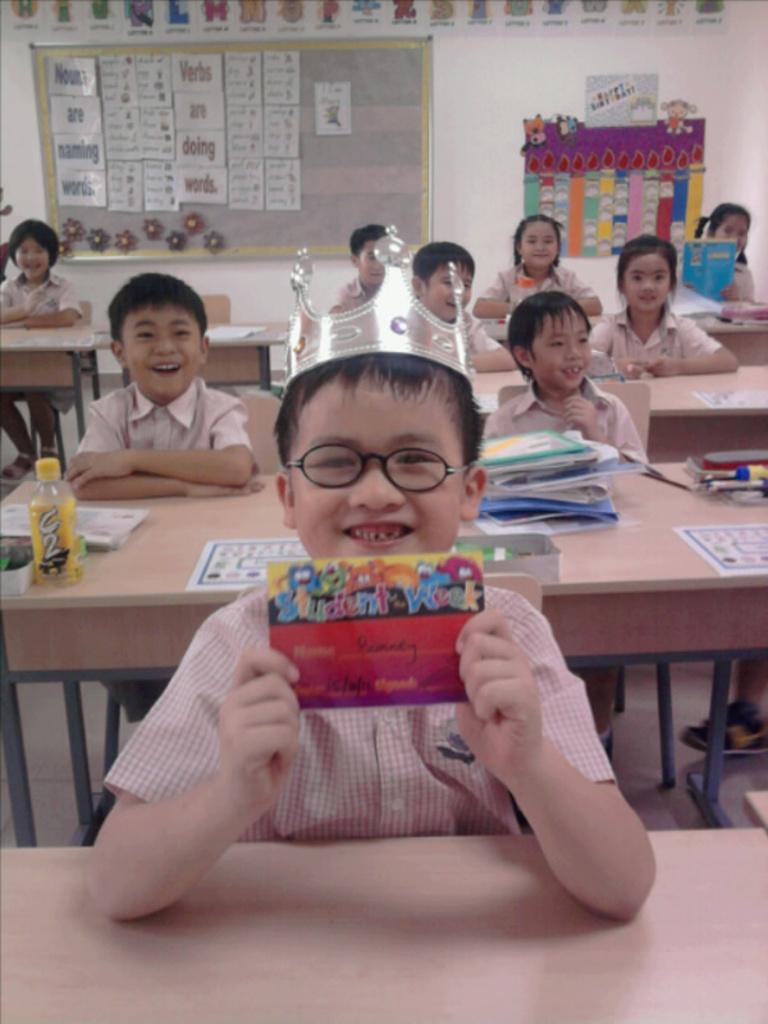Can you describe this image briefly? The image is taken in the classroom. In the center of the image we can see people sitting on the benches. There are bottles, books and some papers placed on the bench. In the background there is a board and we can see some papers attached to the wall. 